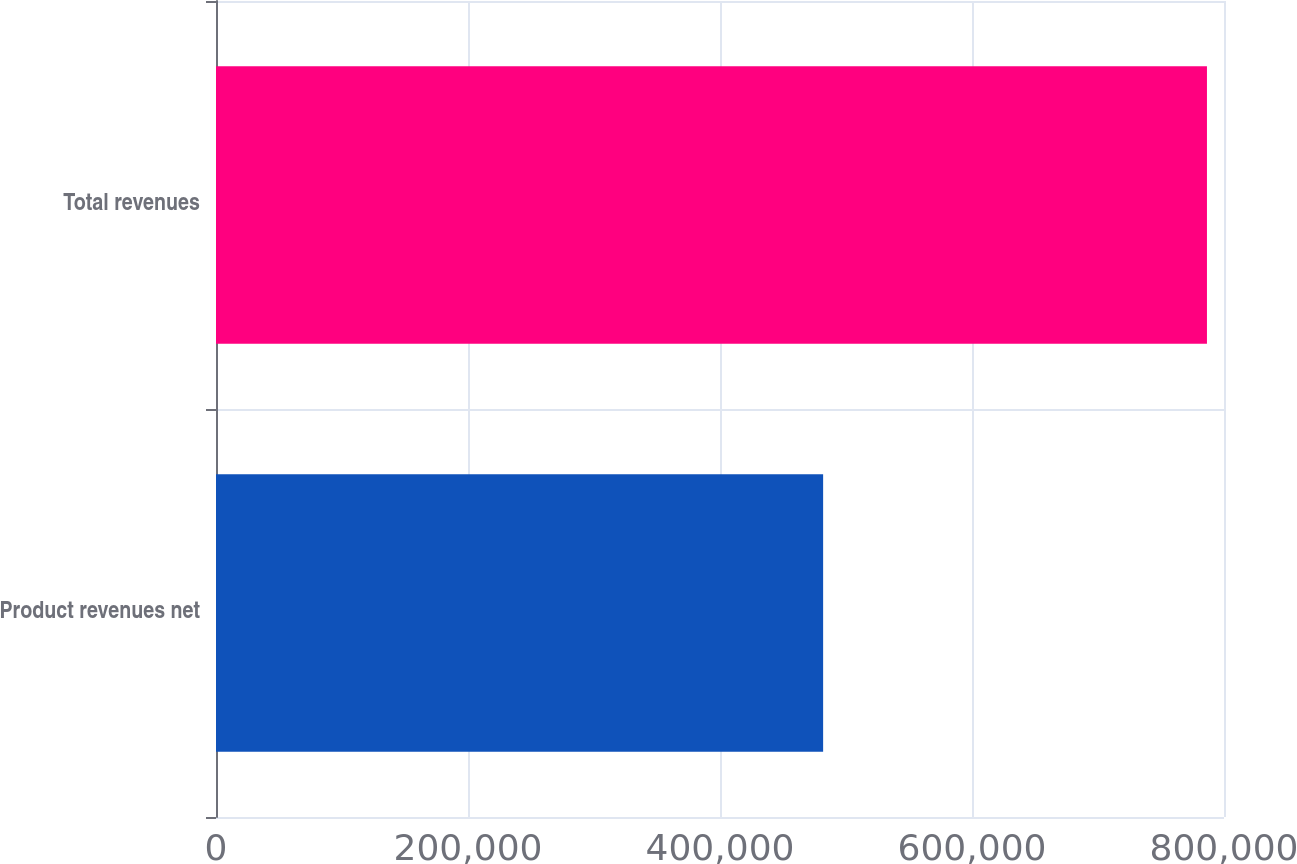<chart> <loc_0><loc_0><loc_500><loc_500><bar_chart><fcel>Product revenues net<fcel>Total revenues<nl><fcel>481848<fcel>786475<nl></chart> 